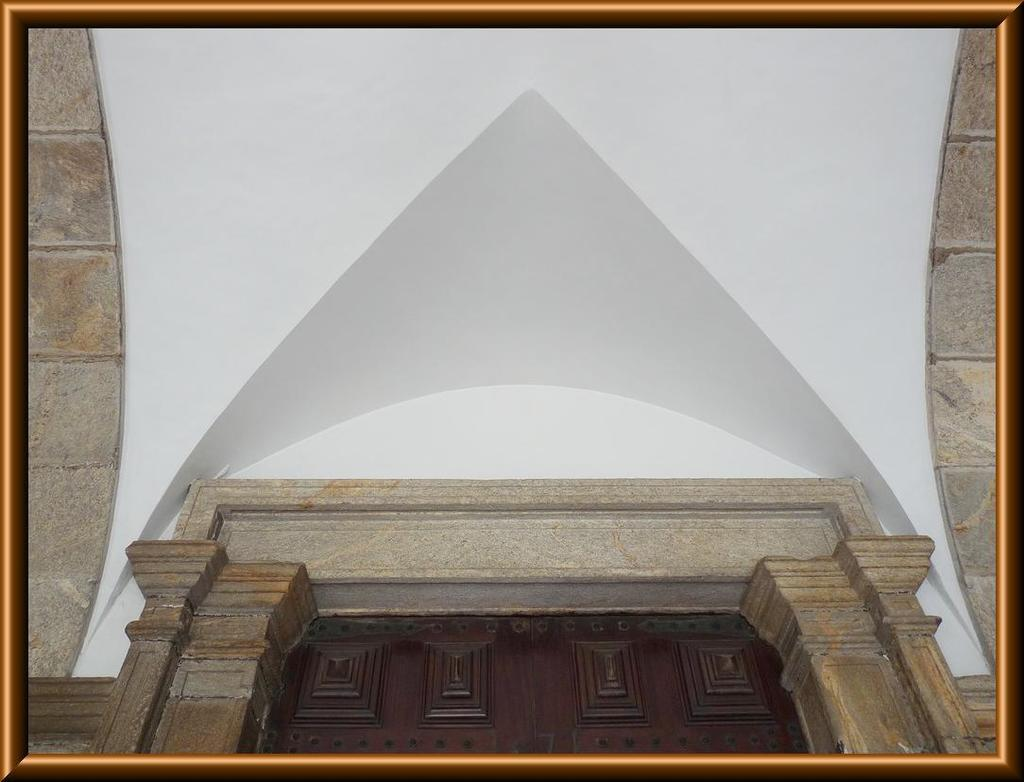What is the main subject of the image? The main subject of the image is a frame of a building. Can you describe the building in the image? Unfortunately, the provided facts do not give any details about the building's appearance or features. Is there any context or setting provided for the building in the image? No, the only information given is that there is a frame of a building in the image. What type of family is represented in the image? There is no family present in the image; it only features a frame of a building. Can you hear the bell ringing in the image? There is no bell present in the image, so it is not possible to hear it ringing. 